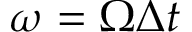Convert formula to latex. <formula><loc_0><loc_0><loc_500><loc_500>\omega = \Omega \Delta t</formula> 